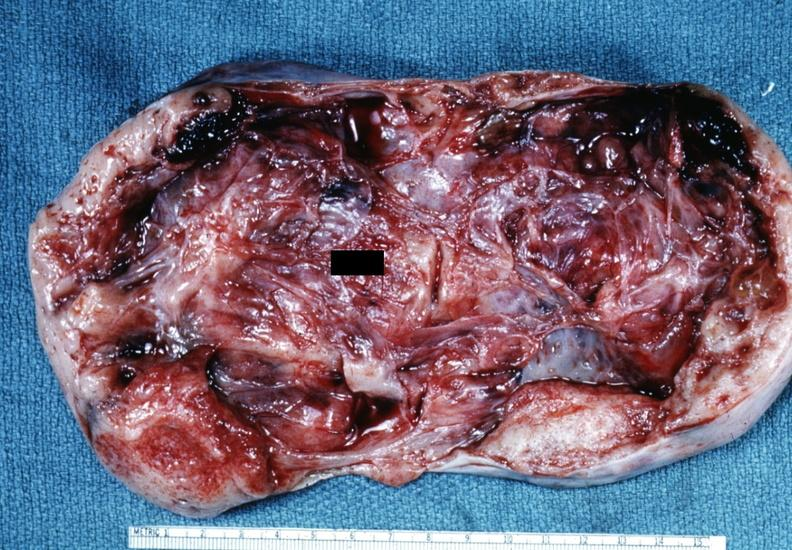s this partially fixed gross not diagnostic?
Answer the question using a single word or phrase. Yes 